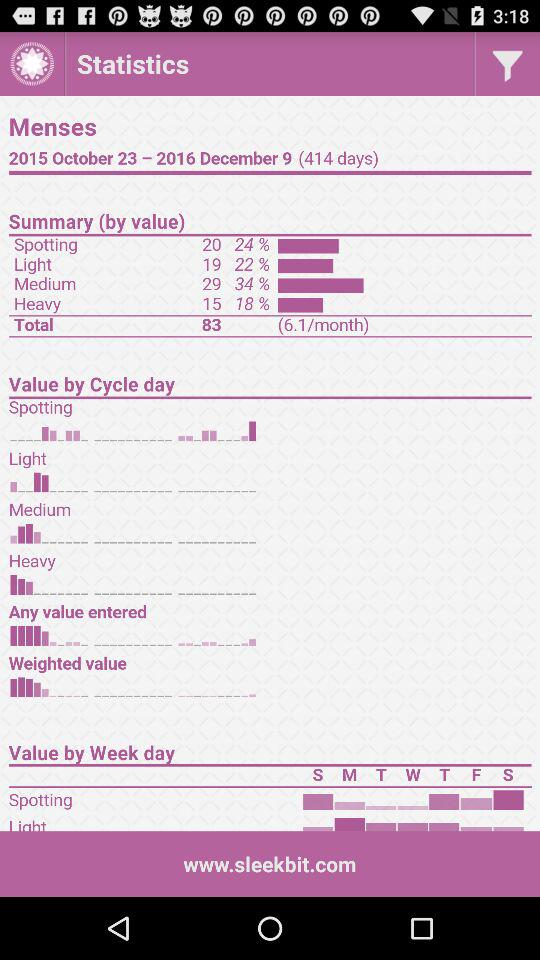What is the total number of days mentioned in "Menses"? The total number of days mentioned in "Menses" is 414. 